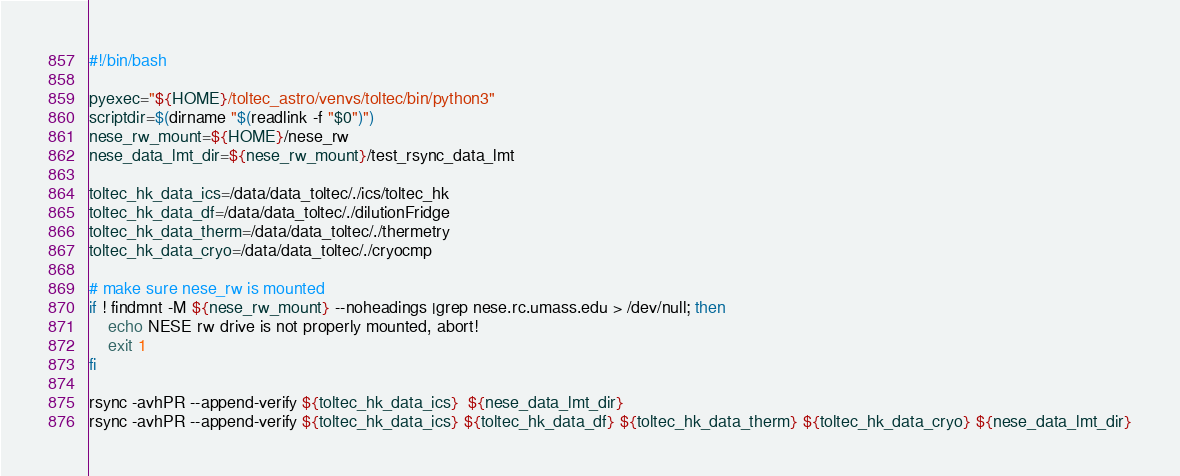Convert code to text. <code><loc_0><loc_0><loc_500><loc_500><_Bash_>#!/bin/bash

pyexec="${HOME}/toltec_astro/venvs/toltec/bin/python3"
scriptdir=$(dirname "$(readlink -f "$0")")
nese_rw_mount=${HOME}/nese_rw
nese_data_lmt_dir=${nese_rw_mount}/test_rsync_data_lmt

toltec_hk_data_ics=/data/data_toltec/./ics/toltec_hk
toltec_hk_data_df=/data/data_toltec/./dilutionFridge
toltec_hk_data_therm=/data/data_toltec/./thermetry
toltec_hk_data_cryo=/data/data_toltec/./cryocmp

# make sure nese_rw is mounted
if ! findmnt -M ${nese_rw_mount} --noheadings |grep nese.rc.umass.edu > /dev/null; then
    echo NESE rw drive is not properly mounted, abort!
    exit 1
fi

rsync -avhPR --append-verify ${toltec_hk_data_ics}  ${nese_data_lmt_dir}
rsync -avhPR --append-verify ${toltec_hk_data_ics} ${toltec_hk_data_df} ${toltec_hk_data_therm} ${toltec_hk_data_cryo} ${nese_data_lmt_dir}
</code> 